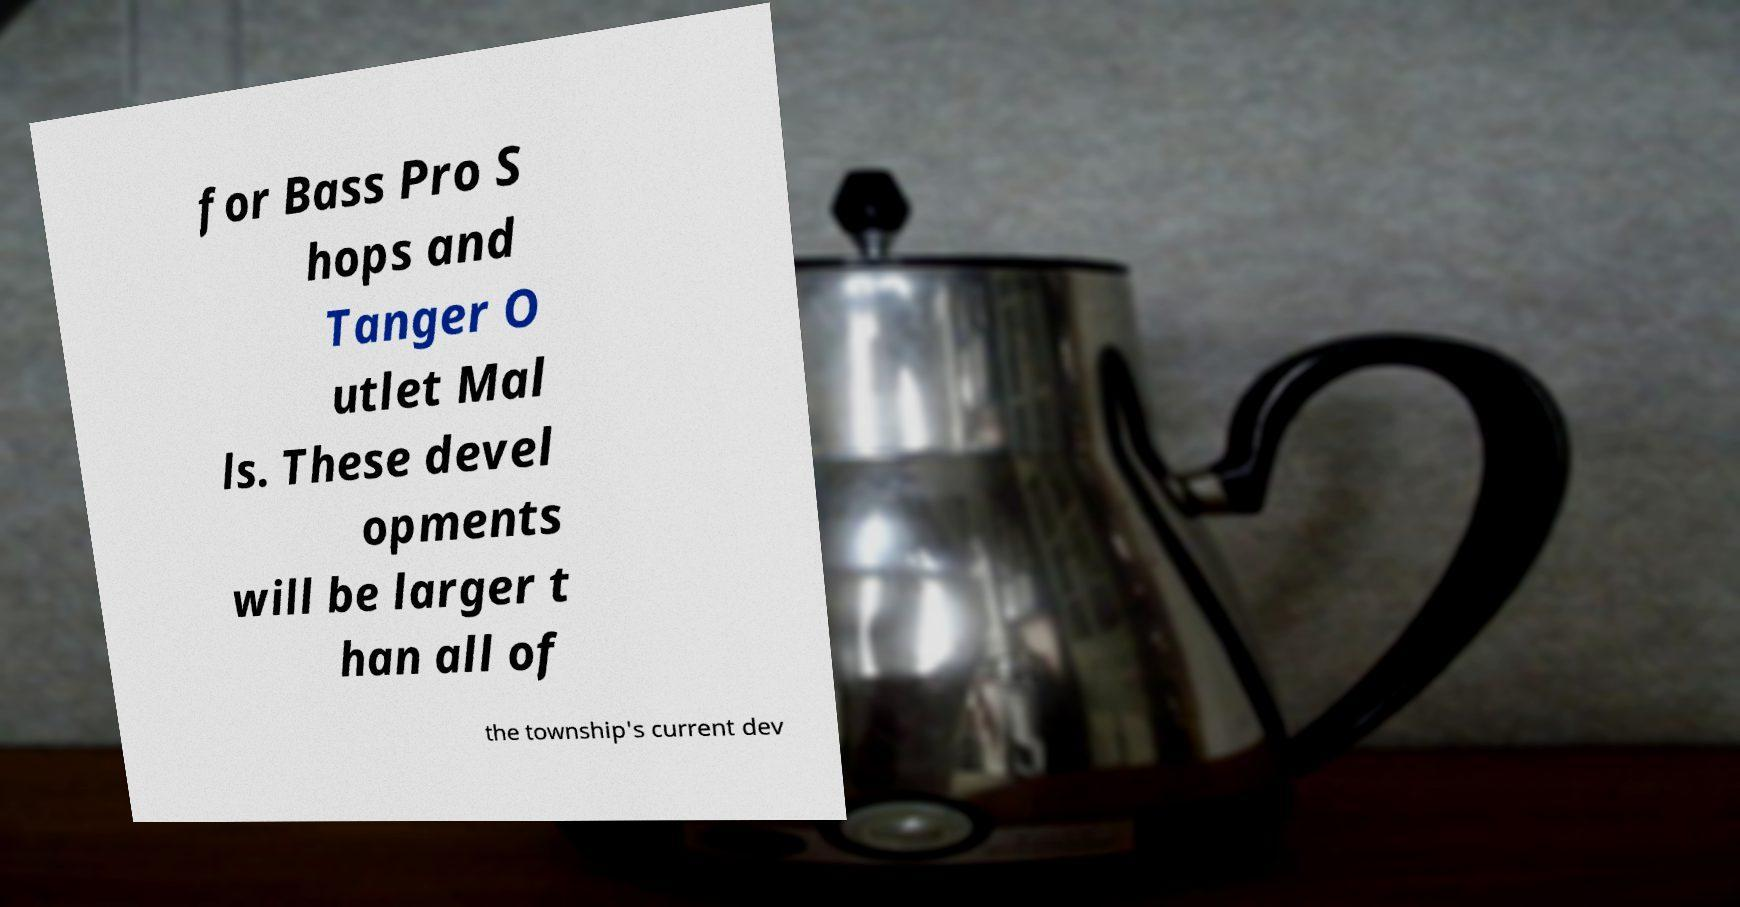Could you assist in decoding the text presented in this image and type it out clearly? for Bass Pro S hops and Tanger O utlet Mal ls. These devel opments will be larger t han all of the township's current dev 